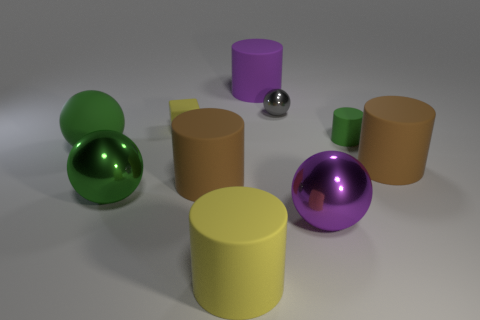Can you describe the texture of the green spherical object on the left? The green spherical object has a smooth, reflective surface suggesting it might be made of a polished material like glass or a lacquered wood. 